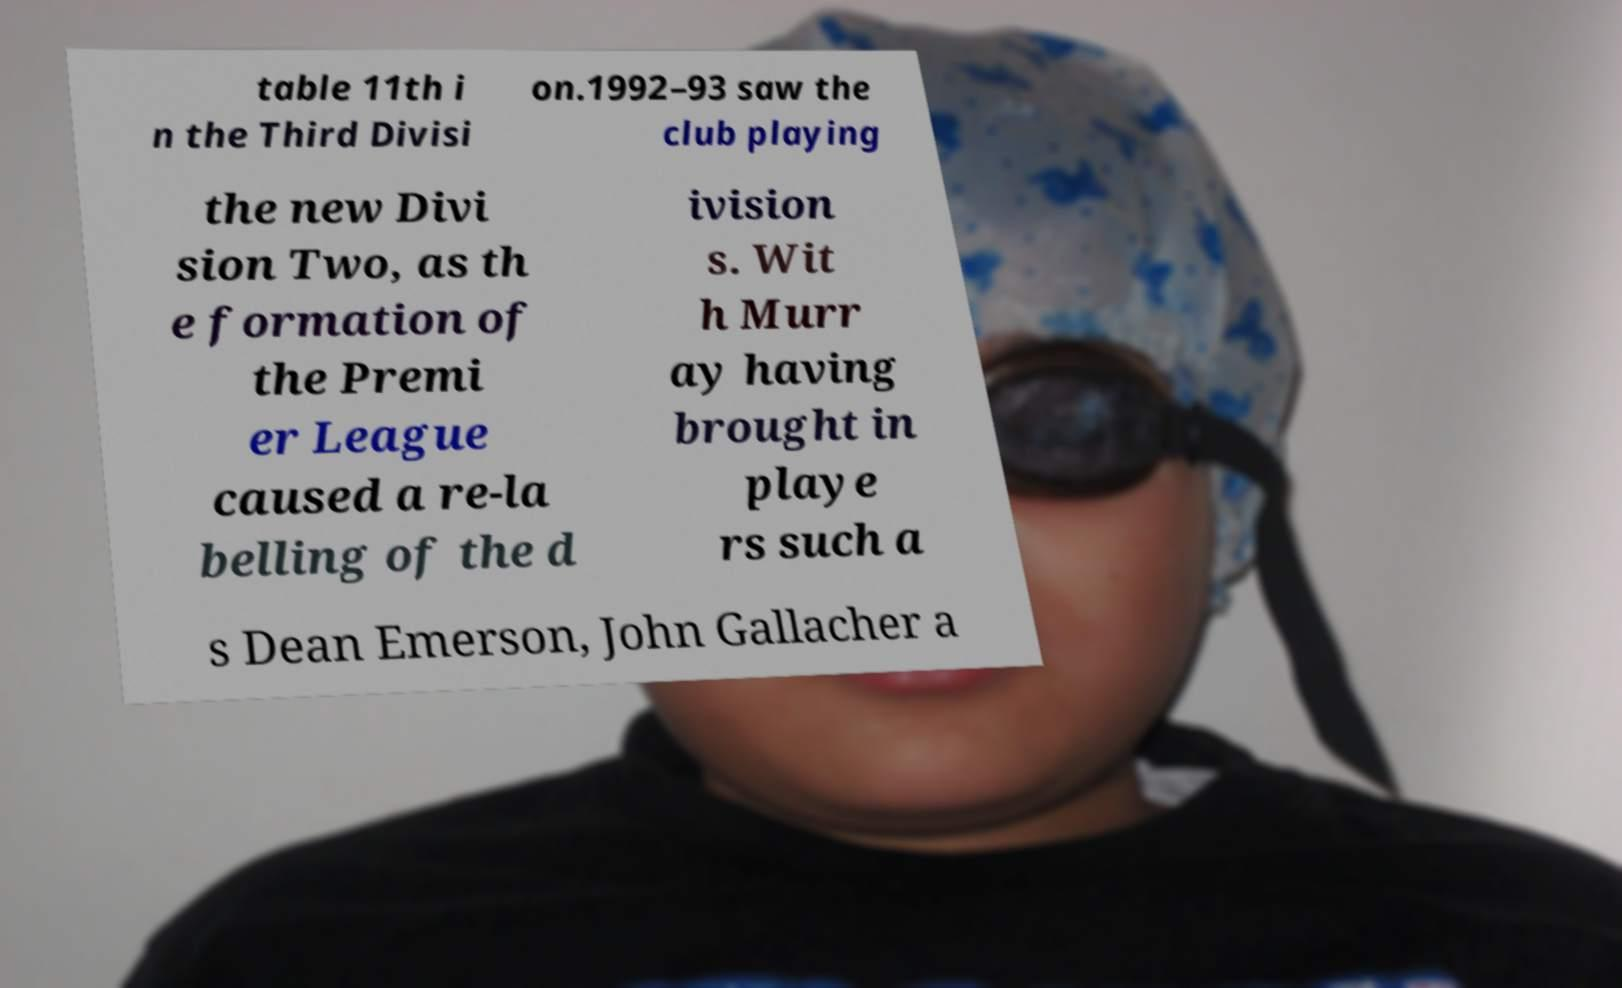Could you assist in decoding the text presented in this image and type it out clearly? table 11th i n the Third Divisi on.1992–93 saw the club playing the new Divi sion Two, as th e formation of the Premi er League caused a re-la belling of the d ivision s. Wit h Murr ay having brought in playe rs such a s Dean Emerson, John Gallacher a 